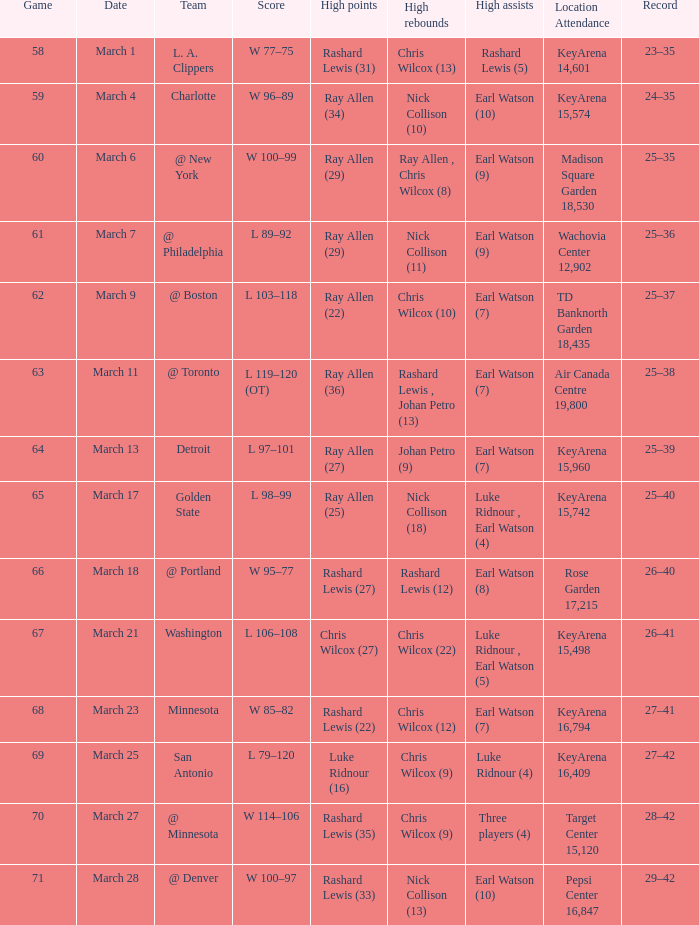Who had the maximum points in the contest on march 7? Ray Allen (29). 